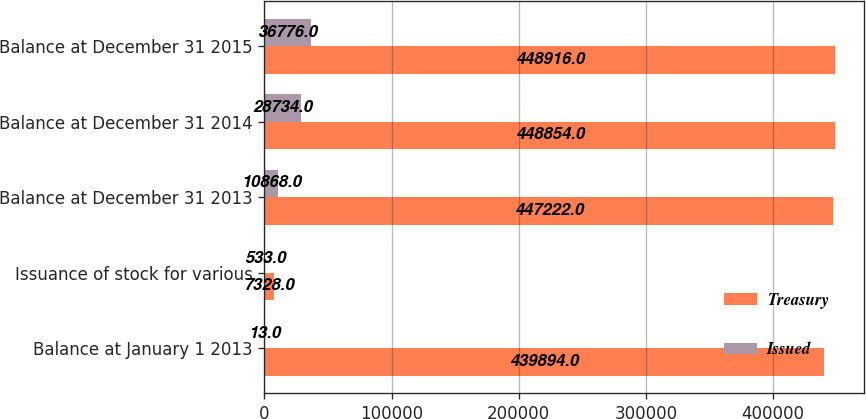<chart> <loc_0><loc_0><loc_500><loc_500><stacked_bar_chart><ecel><fcel>Balance at January 1 2013<fcel>Issuance of stock for various<fcel>Balance at December 31 2013<fcel>Balance at December 31 2014<fcel>Balance at December 31 2015<nl><fcel>Treasury<fcel>439894<fcel>7328<fcel>447222<fcel>448854<fcel>448916<nl><fcel>Issued<fcel>13<fcel>533<fcel>10868<fcel>28734<fcel>36776<nl></chart> 